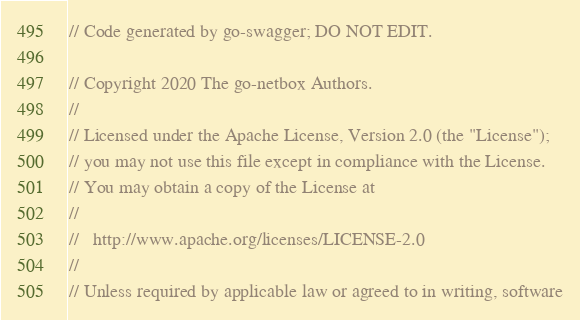Convert code to text. <code><loc_0><loc_0><loc_500><loc_500><_Go_>// Code generated by go-swagger; DO NOT EDIT.

// Copyright 2020 The go-netbox Authors.
//
// Licensed under the Apache License, Version 2.0 (the "License");
// you may not use this file except in compliance with the License.
// You may obtain a copy of the License at
//
//   http://www.apache.org/licenses/LICENSE-2.0
//
// Unless required by applicable law or agreed to in writing, software</code> 